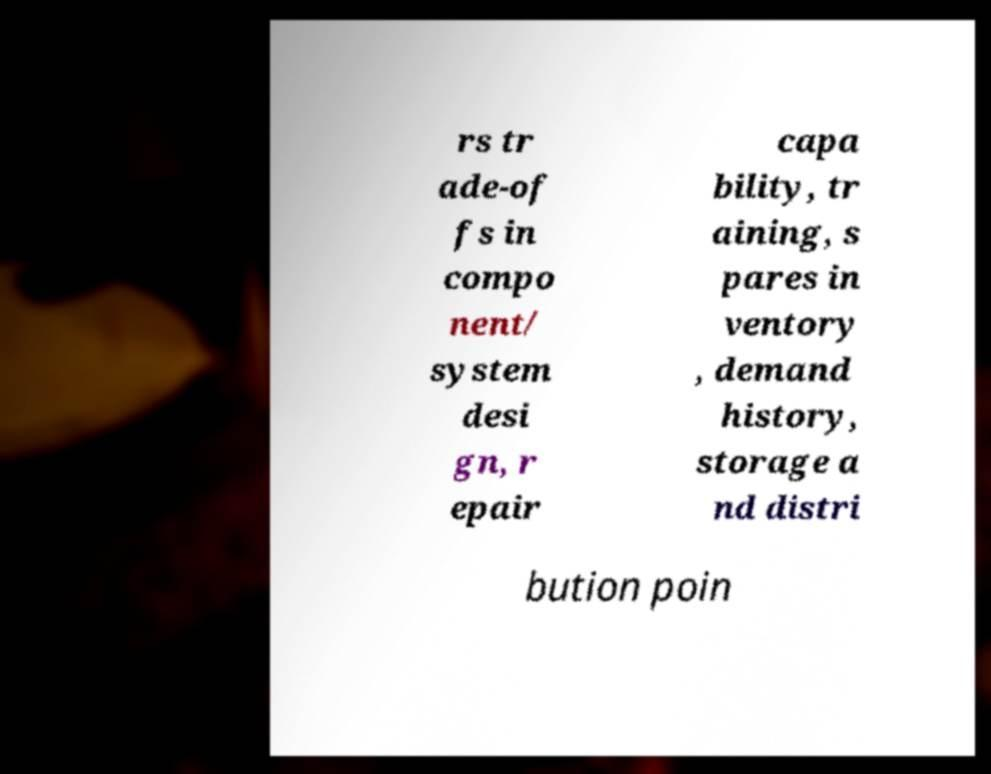Please read and relay the text visible in this image. What does it say? rs tr ade-of fs in compo nent/ system desi gn, r epair capa bility, tr aining, s pares in ventory , demand history, storage a nd distri bution poin 